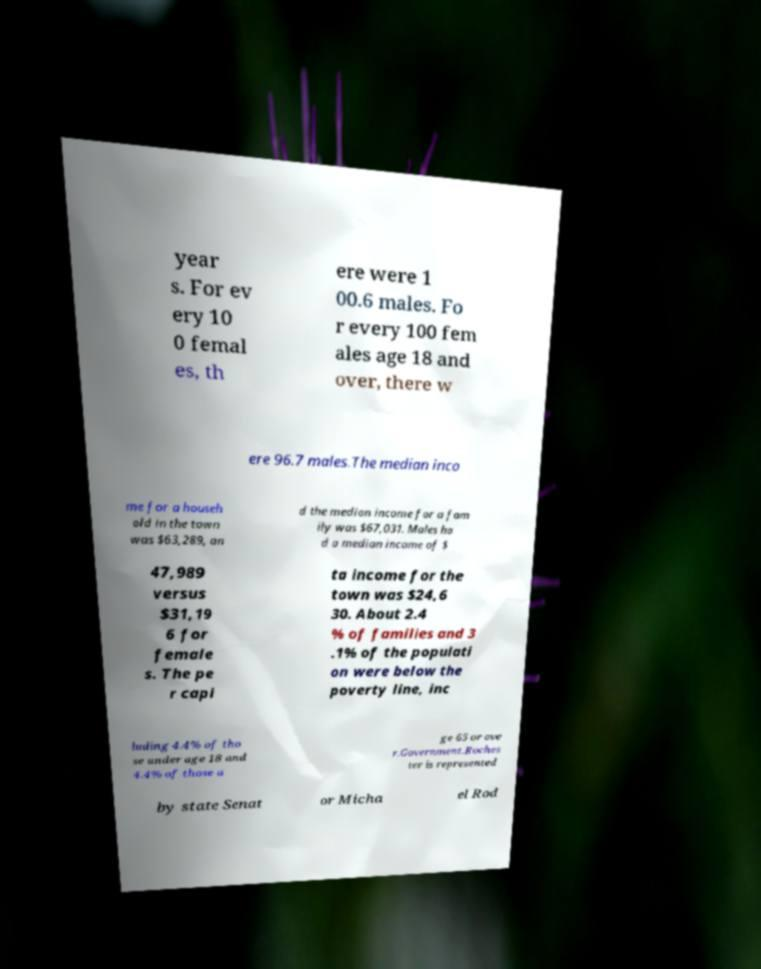Can you accurately transcribe the text from the provided image for me? year s. For ev ery 10 0 femal es, th ere were 1 00.6 males. Fo r every 100 fem ales age 18 and over, there w ere 96.7 males.The median inco me for a househ old in the town was $63,289, an d the median income for a fam ily was $67,031. Males ha d a median income of $ 47,989 versus $31,19 6 for female s. The pe r capi ta income for the town was $24,6 30. About 2.4 % of families and 3 .1% of the populati on were below the poverty line, inc luding 4.4% of tho se under age 18 and 4.4% of those a ge 65 or ove r.Government.Roches ter is represented by state Senat or Micha el Rod 